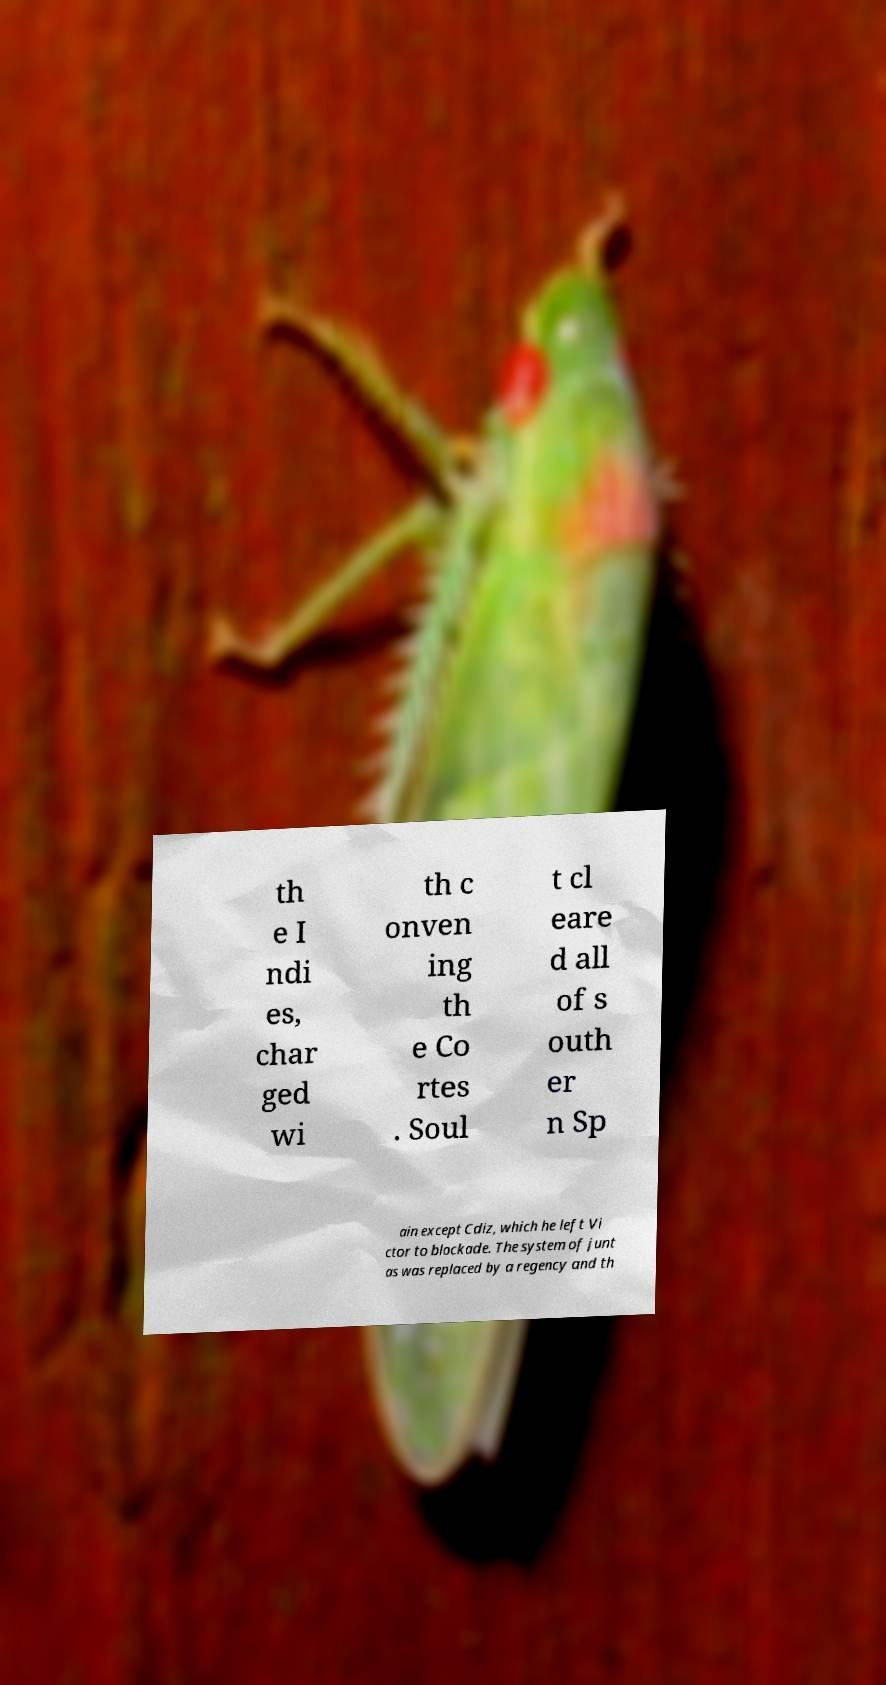Could you assist in decoding the text presented in this image and type it out clearly? th e I ndi es, char ged wi th c onven ing th e Co rtes . Soul t cl eare d all of s outh er n Sp ain except Cdiz, which he left Vi ctor to blockade. The system of junt as was replaced by a regency and th 